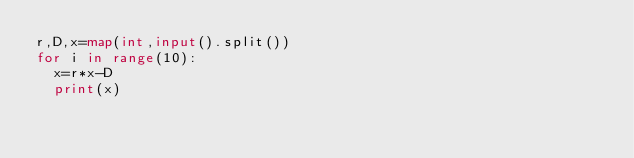Convert code to text. <code><loc_0><loc_0><loc_500><loc_500><_Python_>r,D,x=map(int,input().split())
for i in range(10):
  x=r*x-D
  print(x)</code> 